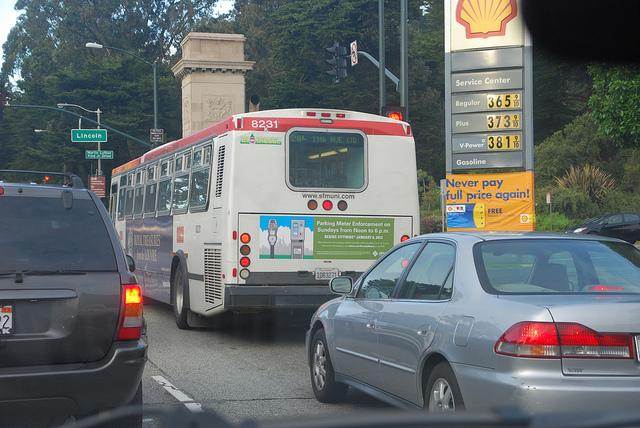What does the business sell? gas 